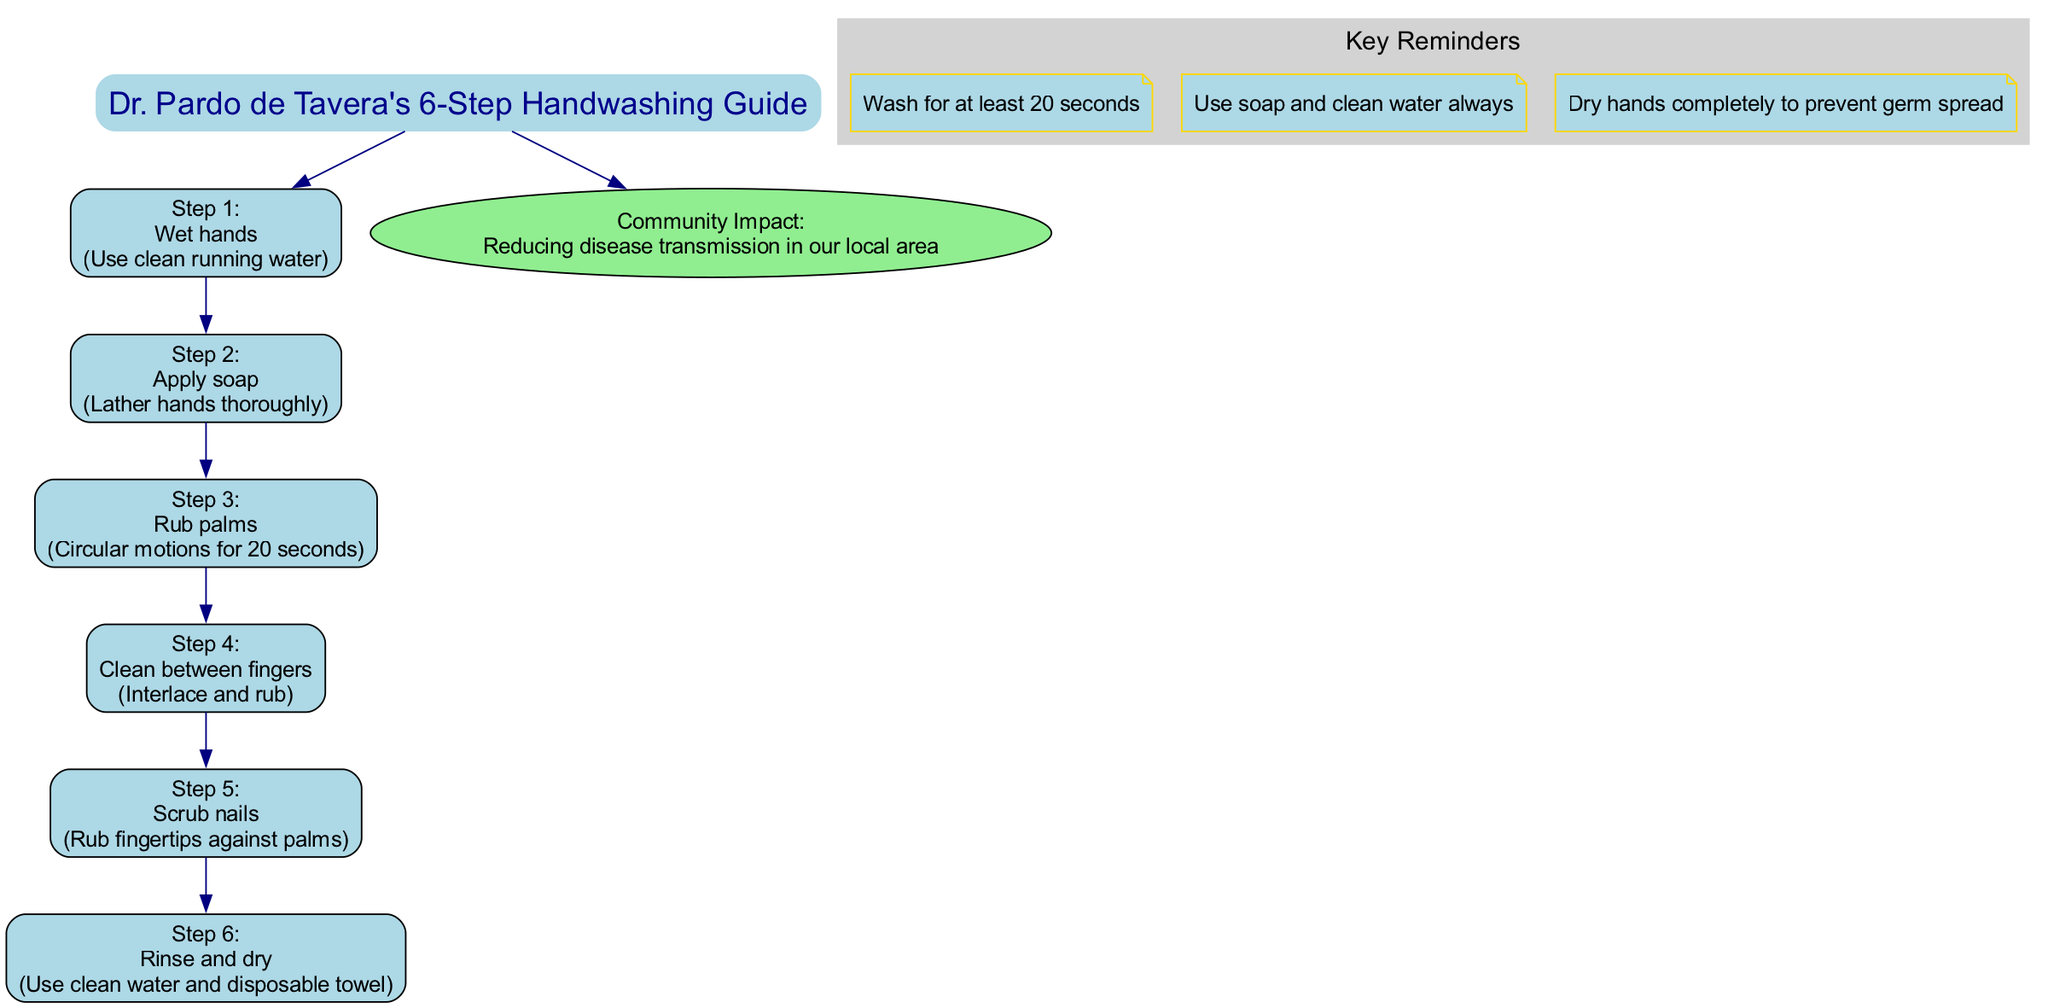What is the first step in the handwashing guide? The first step listed in the diagram is to "Wet hands." This is found at the top of the flow, indicating the order of actions in the handwashing process.
Answer: Wet hands How many key reminders are included in the diagram? The section for key reminders has three nodes listed therein, each representing a specific reminder about handwashing practices. Counting these gives the total number of reminders.
Answer: 3 What action follows "Apply soap"? The diagram shows that "Apply soap" is followed by "Rub palms," indicating the sequence of actions to be taken while handwashing.
Answer: Rub palms What is the community impact stated in the diagram? According to the information presented at the bottom of the diagram, the community impact of the handwashing guide is "Reducing disease transmission in our local area." This highlights the significance of the handwashing steps.
Answer: Reducing disease transmission in our local area What should hands be dried with after rinsing? The diagram specifies to use a "disposable towel" for drying hands, indicating the requested material for effective hand hygiene.
Answer: Disposable towel What action is performed during step 4? The diagram details step 4 as "Clean between fingers," which outlines a specific action to ensure thorough cleaning of the hands.
Answer: Clean between fingers How long should the handwashing process be performed? The key reminders section emphasizes washing for "at least 20 seconds," indicating the necessary duration for effective handwashing.
Answer: At least 20 seconds What color represents the key reminders cluster in the diagram? The cluster of key reminders is filled with "lightgrey" color according to the diagram's visual design, which distinguishes it from other parts of the diagram.
Answer: Lightgrey 